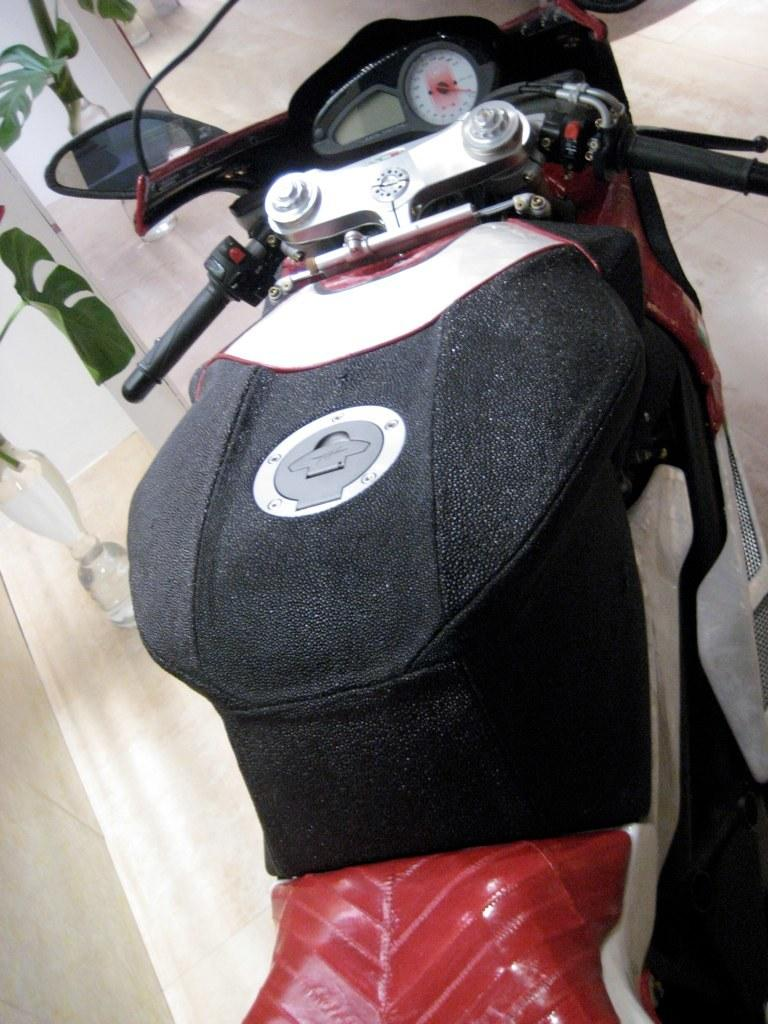What is the main subject of the image? The main subject of the image is a motorbike. What can be seen in the background of the image? There is a surface visible in the background of the image. What is located on the left side of the image? There are plants with bottles on the left side of the image. What type of leather is used to make the instrument in the image? There is no instrument present in the image, so it is not possible to determine what type of leather might be used. How much rice is visible in the image? There is no rice present in the image, so it is not possible to determine the amount. 